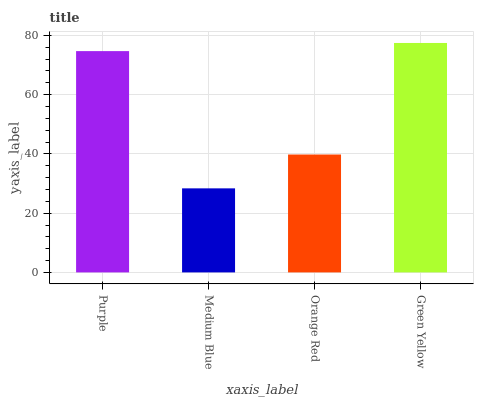Is Medium Blue the minimum?
Answer yes or no. Yes. Is Green Yellow the maximum?
Answer yes or no. Yes. Is Orange Red the minimum?
Answer yes or no. No. Is Orange Red the maximum?
Answer yes or no. No. Is Orange Red greater than Medium Blue?
Answer yes or no. Yes. Is Medium Blue less than Orange Red?
Answer yes or no. Yes. Is Medium Blue greater than Orange Red?
Answer yes or no. No. Is Orange Red less than Medium Blue?
Answer yes or no. No. Is Purple the high median?
Answer yes or no. Yes. Is Orange Red the low median?
Answer yes or no. Yes. Is Orange Red the high median?
Answer yes or no. No. Is Medium Blue the low median?
Answer yes or no. No. 